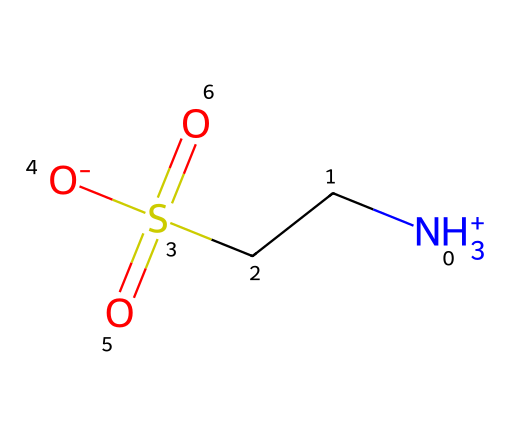How many nitrogen atoms are in taurine? The SMILES representation includes one nitrogen atom indicated by "N". There are no other nitrogen symbols present in the chemical structure.
Answer: one What is the total number of sulfur atoms in taurine? The SMILES notation includes one sulfur atom represented by "S" in the chain. There are no additional sulfur atoms shown in the structure.
Answer: one What functional group is present in taurine? The structure contains a sulfonic acid functional group, which can be identified by the "S" followed by "(=O)=O" in the SMILES, indicating the presence of two double-bonded oxygen atoms and one single-bonded oxygen atom to sulfur.
Answer: sulfonic acid How many total oxygen atoms are present in taurine? By analyzing the SMILES, the "O" appears three times: twice in the sulfonic acid group and once attached to sulfur. This indicates a total of three oxygen atoms in the structure.
Answer: three What is the overall charge of taurine? In the SMILES representation, the nitrogen atom has a positive charge indicated by "[NH3+]", while the sulfonic acid group has a negative charge represented by "[O-]". The charges balance out to give an overall neutral molecule, as there is one positive and one negative charge.
Answer: neutral What is the main element backbone in taurine? The main chain of taurine is primarily made of carbon atoms, as indicated by the "CC" segment in the SMILES. These two carbon atoms provide the backbone structure of the amino acid.
Answer: carbon Does taurine contain any aromatic rings? The SMILES structure does not include any cyclic (ring) structures or double bonds adjacent to carbon atoms that are typical for aromatic compounds. Thus, taurine does not feature an aromatic ring.
Answer: no 